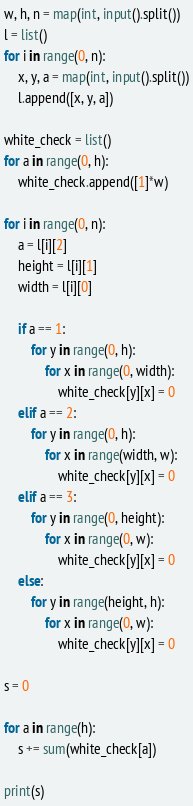Convert code to text. <code><loc_0><loc_0><loc_500><loc_500><_Python_>w, h, n = map(int, input().split())
l = list()
for i in range(0, n):
    x, y, a = map(int, input().split())
    l.append([x, y, a])

white_check = list()
for a in range(0, h):
    white_check.append([1]*w)

for i in range(0, n):
    a = l[i][2]
    height = l[i][1]
    width = l[i][0]

    if a == 1:
        for y in range(0, h):
            for x in range(0, width):
                white_check[y][x] = 0
    elif a == 2:
        for y in range(0, h):
            for x in range(width, w):
                white_check[y][x] = 0
    elif a == 3:
        for y in range(0, height):
            for x in range(0, w):
                white_check[y][x] = 0
    else:
        for y in range(height, h):
            for x in range(0, w):
                white_check[y][x] = 0

s = 0

for a in range(h):
    s += sum(white_check[a])

print(s)
</code> 